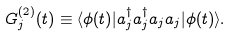<formula> <loc_0><loc_0><loc_500><loc_500>G ^ { ( 2 ) } _ { j } ( t ) \equiv \langle \phi ( t ) | a _ { j } ^ { \dagger } a _ { j } ^ { \dagger } a _ { j } a _ { j } | \phi ( t ) \rangle .</formula> 